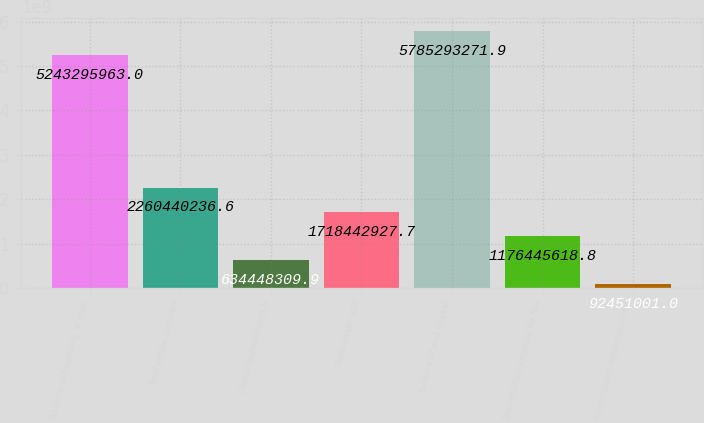Convert chart. <chart><loc_0><loc_0><loc_500><loc_500><bar_chart><fcel>Balance at beginning of year<fcel>Real estate acquired<fcel>Capital expenditures &<fcel>Real estate sold<fcel>Balance at end of year<fcel>Depreciation expense for the<fcel>Accumulated depreciation on<nl><fcel>5.2433e+09<fcel>2.26044e+09<fcel>6.34448e+08<fcel>1.71844e+09<fcel>5.78529e+09<fcel>1.17645e+09<fcel>9.2451e+07<nl></chart> 